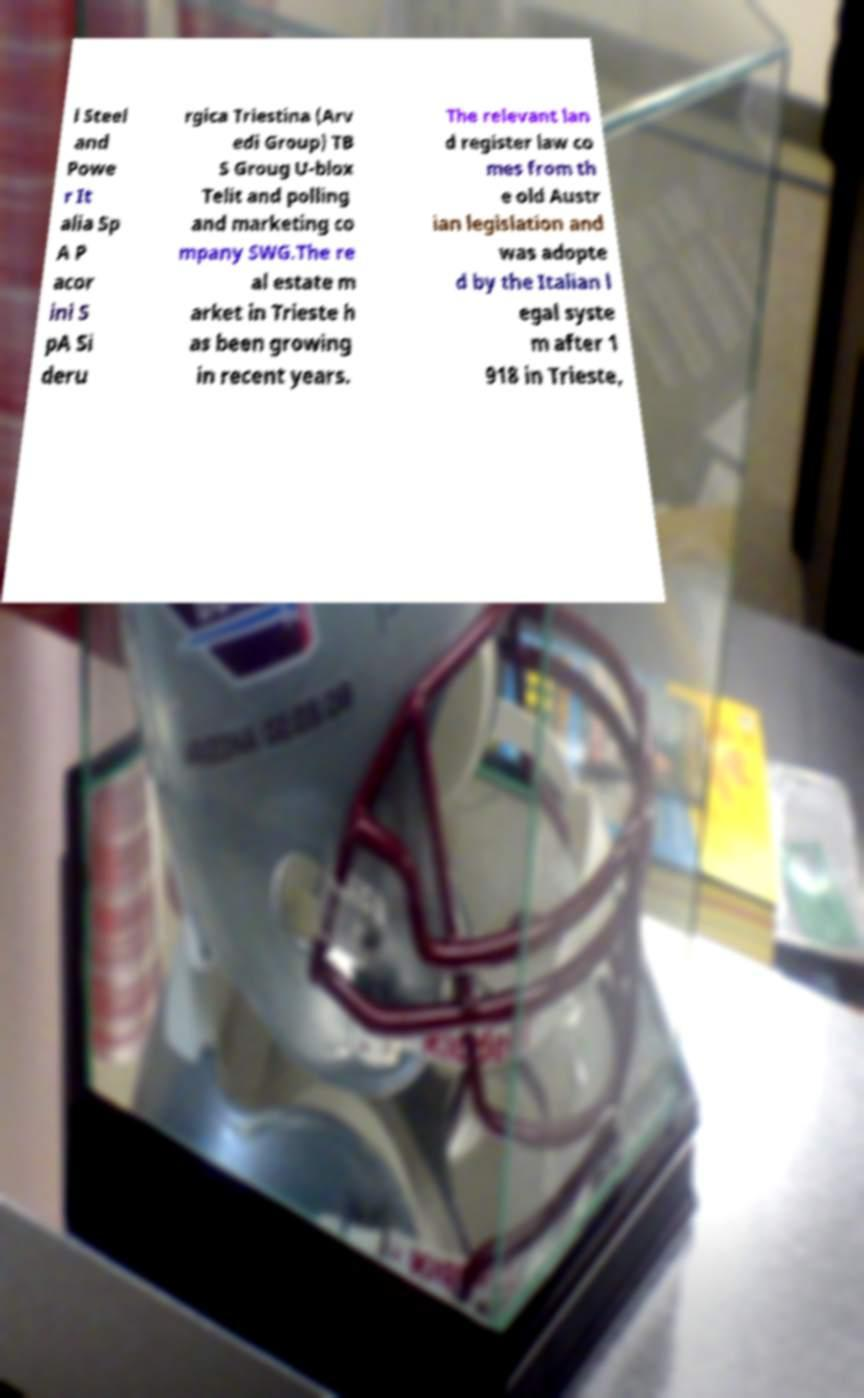Please identify and transcribe the text found in this image. l Steel and Powe r It alia Sp A P acor ini S pA Si deru rgica Triestina (Arv edi Group) TB S Groug U-blox Telit and polling and marketing co mpany SWG.The re al estate m arket in Trieste h as been growing in recent years. The relevant lan d register law co mes from th e old Austr ian legislation and was adopte d by the Italian l egal syste m after 1 918 in Trieste, 